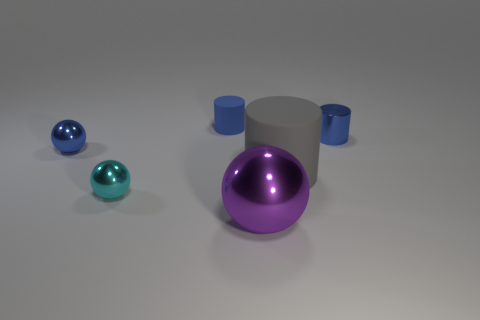Add 1 large rubber things. How many objects exist? 7 Subtract all metal cylinders. Subtract all blue metal balls. How many objects are left? 4 Add 3 large objects. How many large objects are left? 5 Add 6 large shiny balls. How many large shiny balls exist? 7 Subtract 0 brown spheres. How many objects are left? 6 